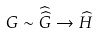Convert formula to latex. <formula><loc_0><loc_0><loc_500><loc_500>G \sim { \widehat { \widehat { G } } } \to { \widehat { H } }</formula> 